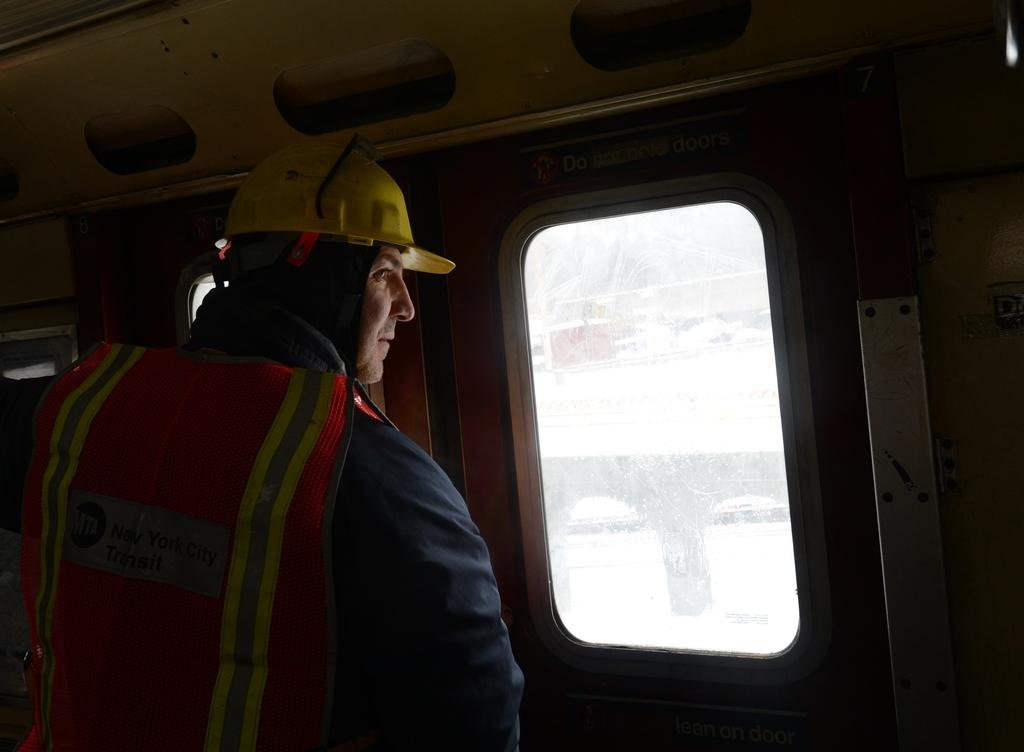Who is present in the image? There is a person in the image. What is the person doing in the image? The person is looking through the window of a vehicle. What can be seen outside the window? There is a bridge visible outside the window. What type of cherries can be seen growing on the bridge in the image? There are no cherries present in the image, and the bridge is not a location where cherries would typically grow. 